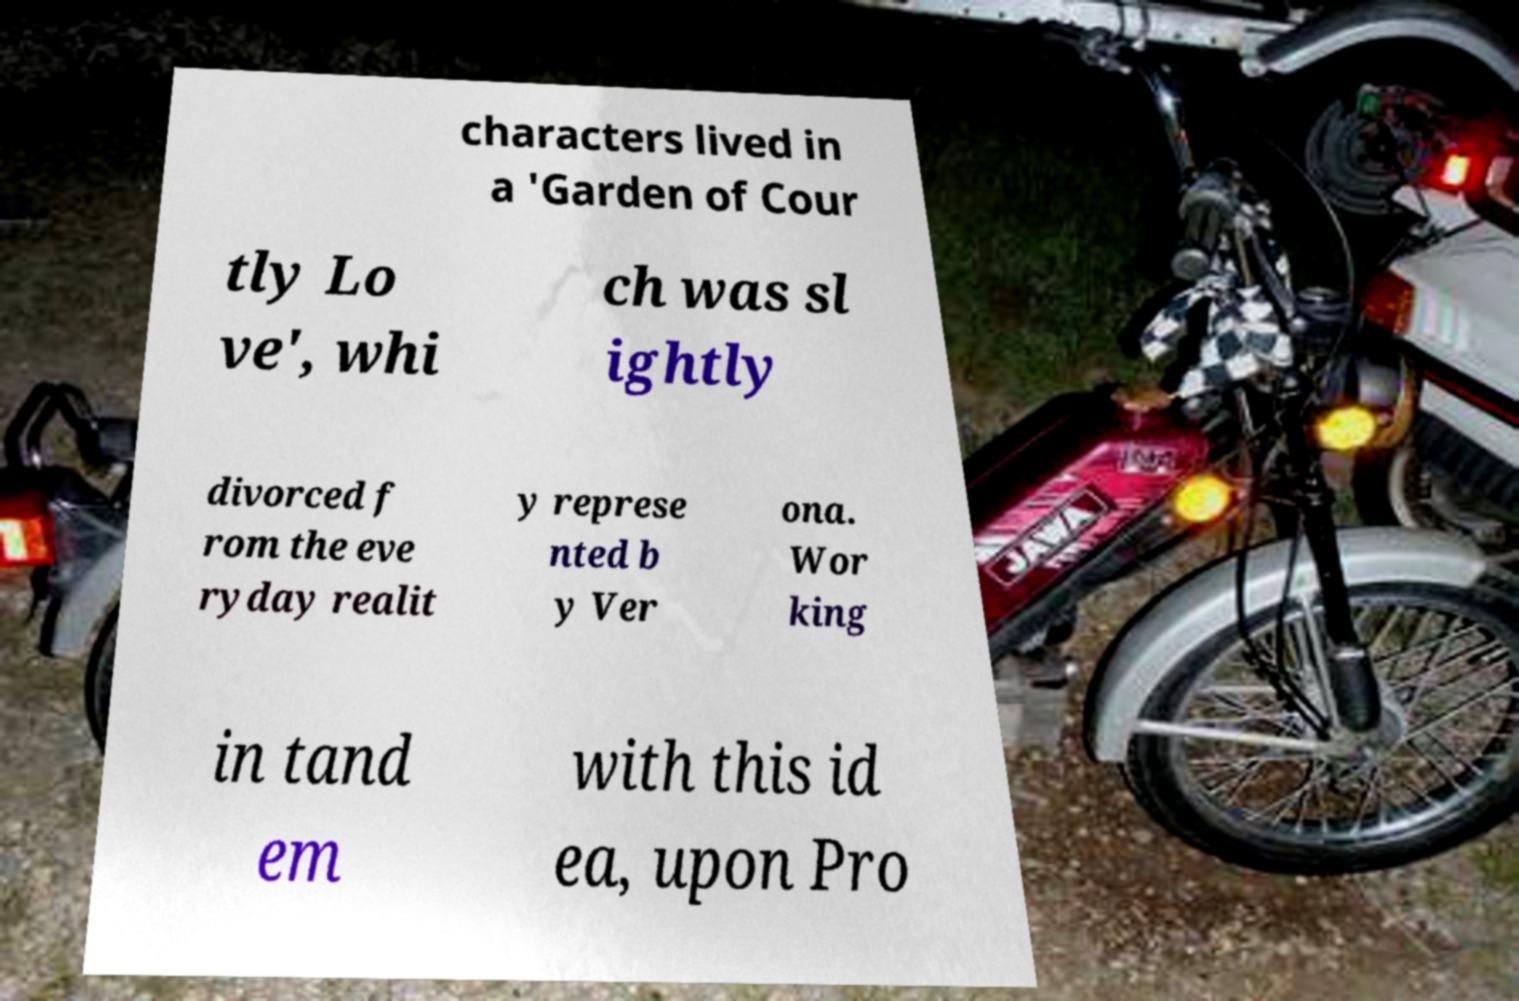Could you assist in decoding the text presented in this image and type it out clearly? characters lived in a 'Garden of Cour tly Lo ve', whi ch was sl ightly divorced f rom the eve ryday realit y represe nted b y Ver ona. Wor king in tand em with this id ea, upon Pro 